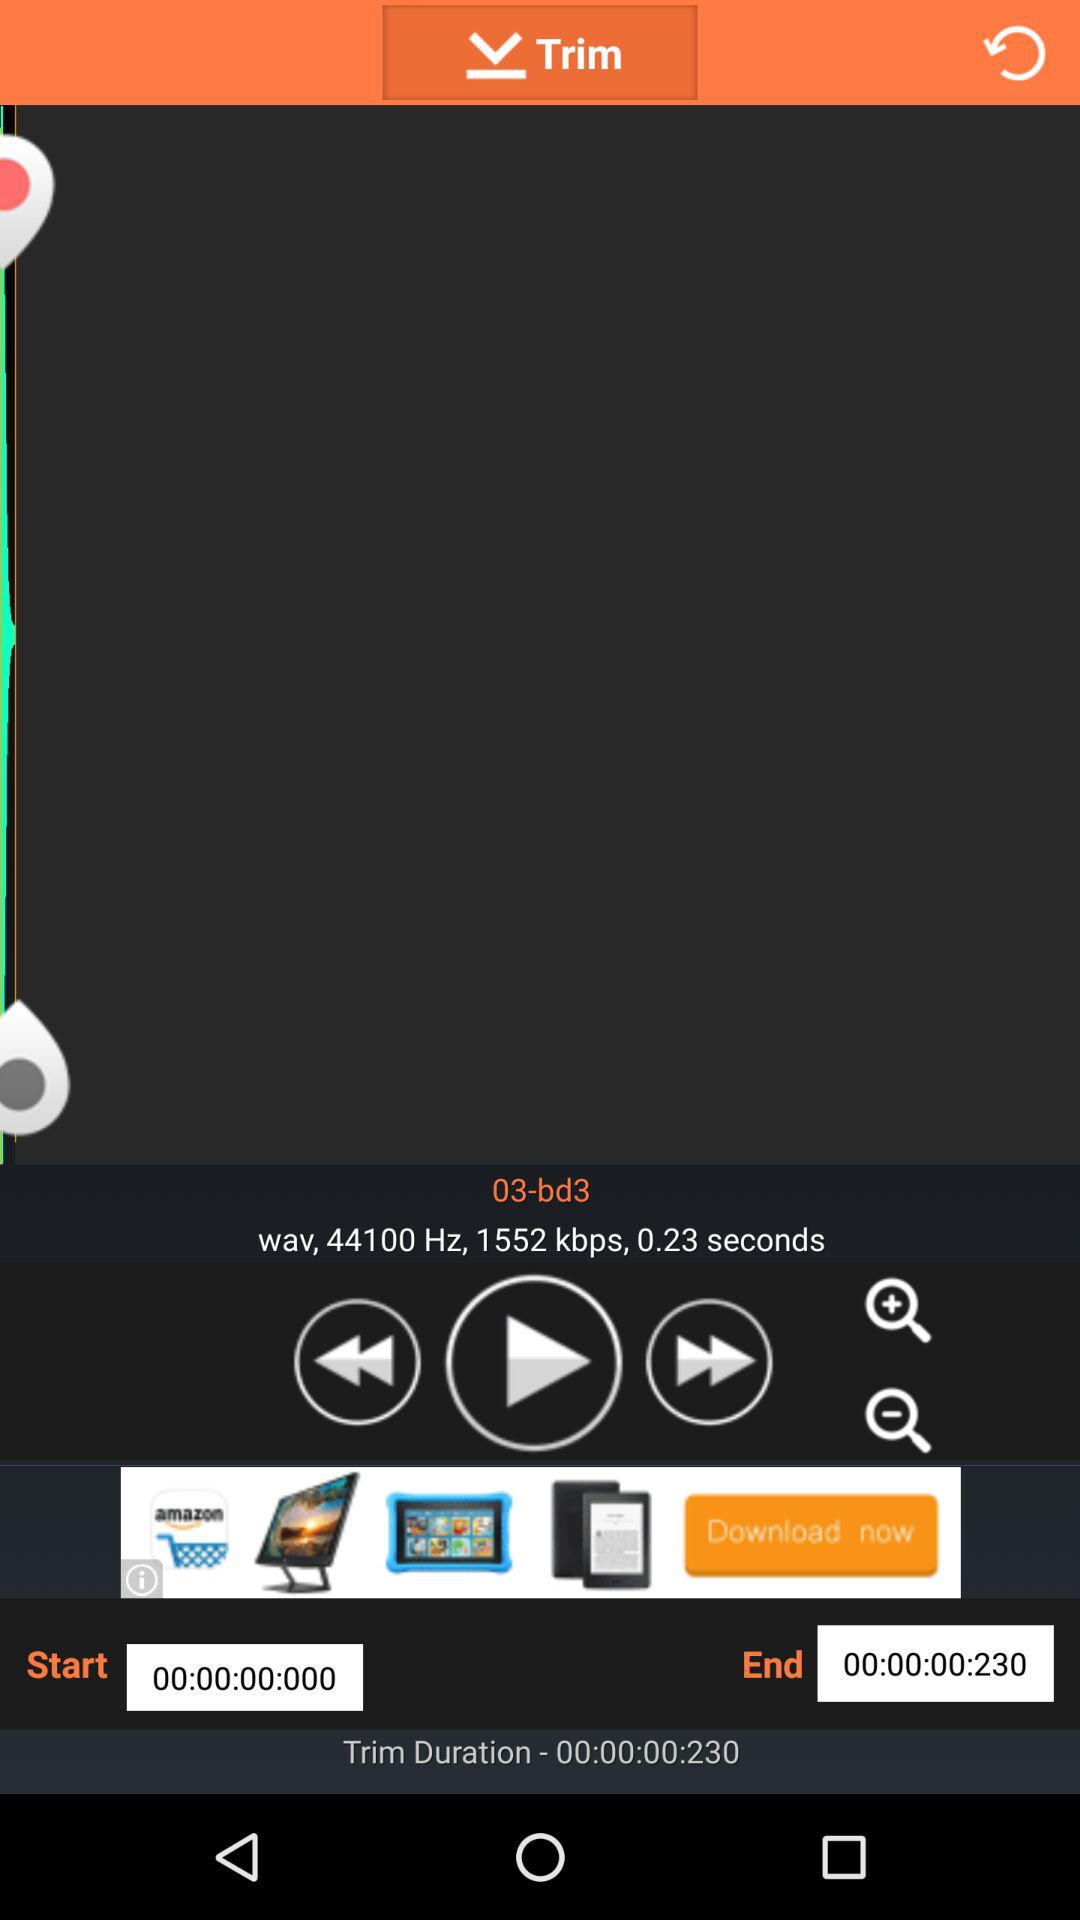How large is "03-bd3" in mb?
When the provided information is insufficient, respond with <no answer>. <no answer> 